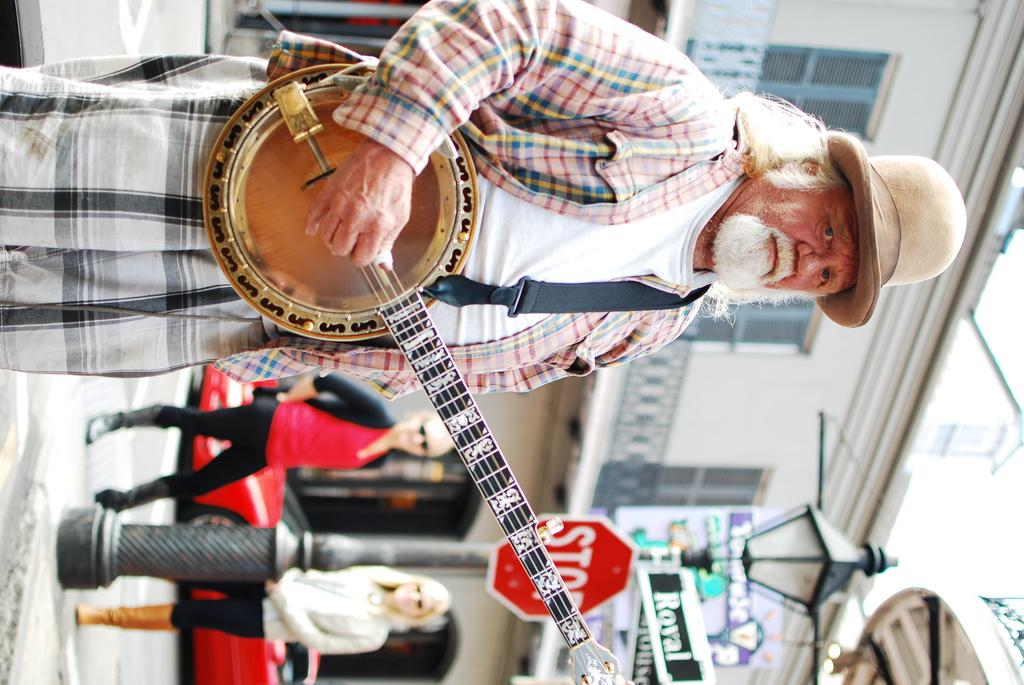What is the old person in the image doing? The old person is playing a music instrument. Can you describe the old person's attire? The old person is wearing a hat. What can be seen in the background of the image? There is a building, a vehicle, a pole, sign boards, lights, and people on the road in the background of the image. What type of house is the old person paying attention to in the image? There is no house present in the image, and the old person is focused on playing a music instrument. What time does the watch in the image show? There is no watch present in the image. 